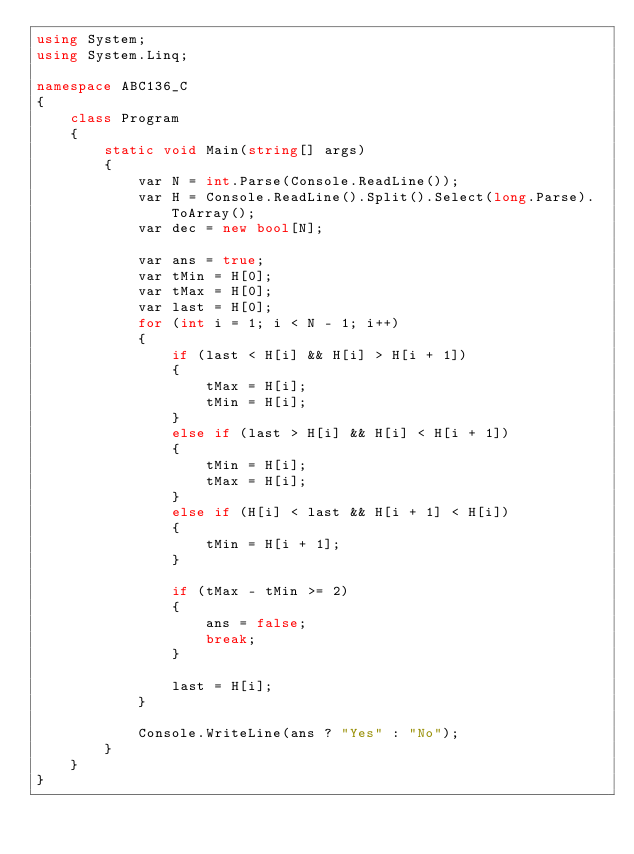Convert code to text. <code><loc_0><loc_0><loc_500><loc_500><_C#_>using System;
using System.Linq;

namespace ABC136_C
{
    class Program
    {
        static void Main(string[] args)
        {
            var N = int.Parse(Console.ReadLine());
            var H = Console.ReadLine().Split().Select(long.Parse).ToArray();
            var dec = new bool[N];

            var ans = true;
            var tMin = H[0];
            var tMax = H[0];
            var last = H[0];
            for (int i = 1; i < N - 1; i++)
            {
                if (last < H[i] && H[i] > H[i + 1])
                {
                    tMax = H[i];
                    tMin = H[i];
                }
                else if (last > H[i] && H[i] < H[i + 1])
                {
                    tMin = H[i];
                    tMax = H[i];
                }
                else if (H[i] < last && H[i + 1] < H[i])
                {
                    tMin = H[i + 1];
                }

                if (tMax - tMin >= 2)
                {
                    ans = false;
                    break;
                }

                last = H[i];
            }

            Console.WriteLine(ans ? "Yes" : "No");
        }
    }
}
</code> 